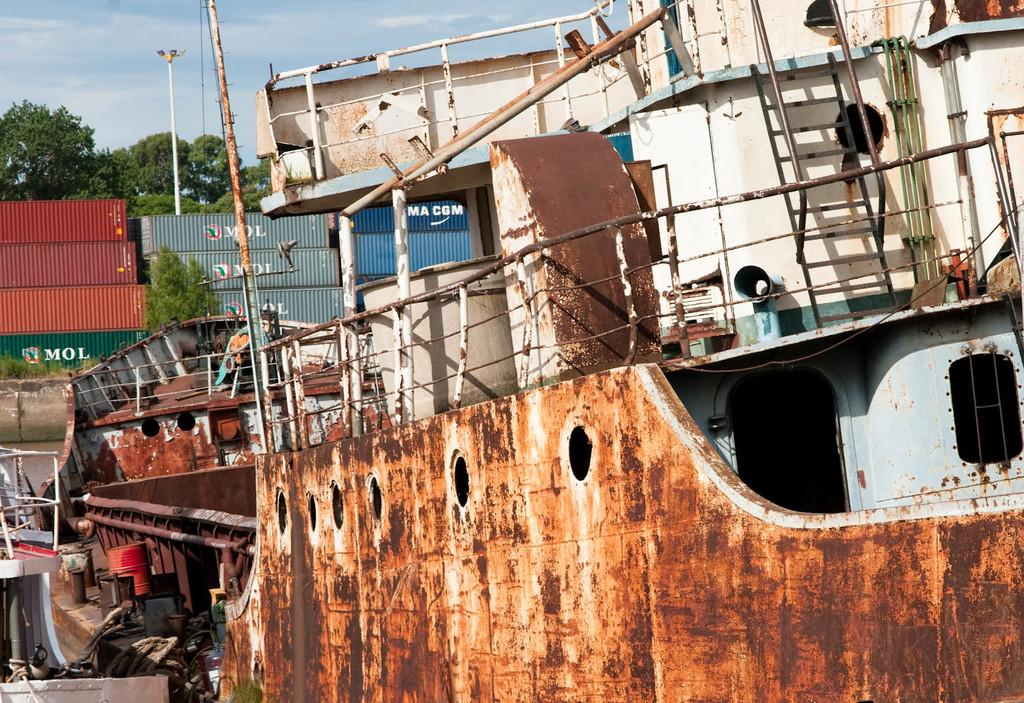<image>
Present a compact description of the photo's key features. A blue building that says MA CGM is in the background of a rusty boat. 